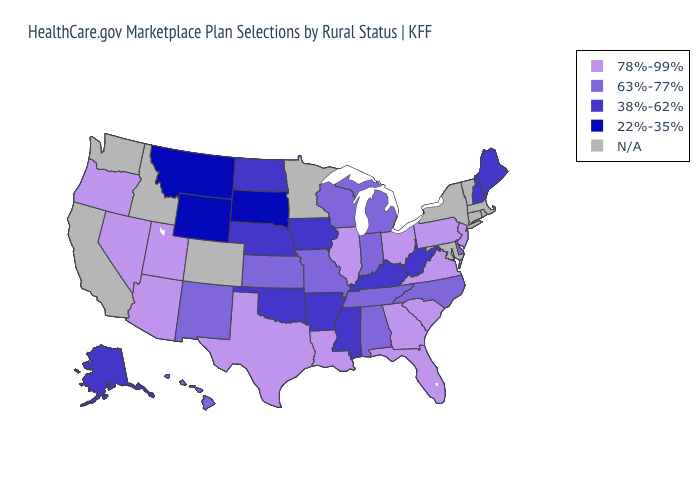Among the states that border Wyoming , which have the highest value?
Give a very brief answer. Utah. What is the value of Louisiana?
Concise answer only. 78%-99%. Among the states that border Missouri , which have the highest value?
Quick response, please. Illinois. Which states have the lowest value in the USA?
Be succinct. Montana, South Dakota, Wyoming. Does Ohio have the highest value in the MidWest?
Quick response, please. Yes. Which states have the highest value in the USA?
Be succinct. Arizona, Florida, Georgia, Illinois, Louisiana, Nevada, New Jersey, Ohio, Oregon, Pennsylvania, South Carolina, Texas, Utah, Virginia. Name the states that have a value in the range 38%-62%?
Quick response, please. Alaska, Arkansas, Iowa, Kentucky, Maine, Mississippi, Nebraska, New Hampshire, North Dakota, Oklahoma, West Virginia. What is the value of South Carolina?
Quick response, please. 78%-99%. Does Virginia have the highest value in the South?
Be succinct. Yes. Does Missouri have the lowest value in the USA?
Give a very brief answer. No. Name the states that have a value in the range 38%-62%?
Keep it brief. Alaska, Arkansas, Iowa, Kentucky, Maine, Mississippi, Nebraska, New Hampshire, North Dakota, Oklahoma, West Virginia. Name the states that have a value in the range 22%-35%?
Be succinct. Montana, South Dakota, Wyoming. What is the value of Wisconsin?
Answer briefly. 63%-77%. 